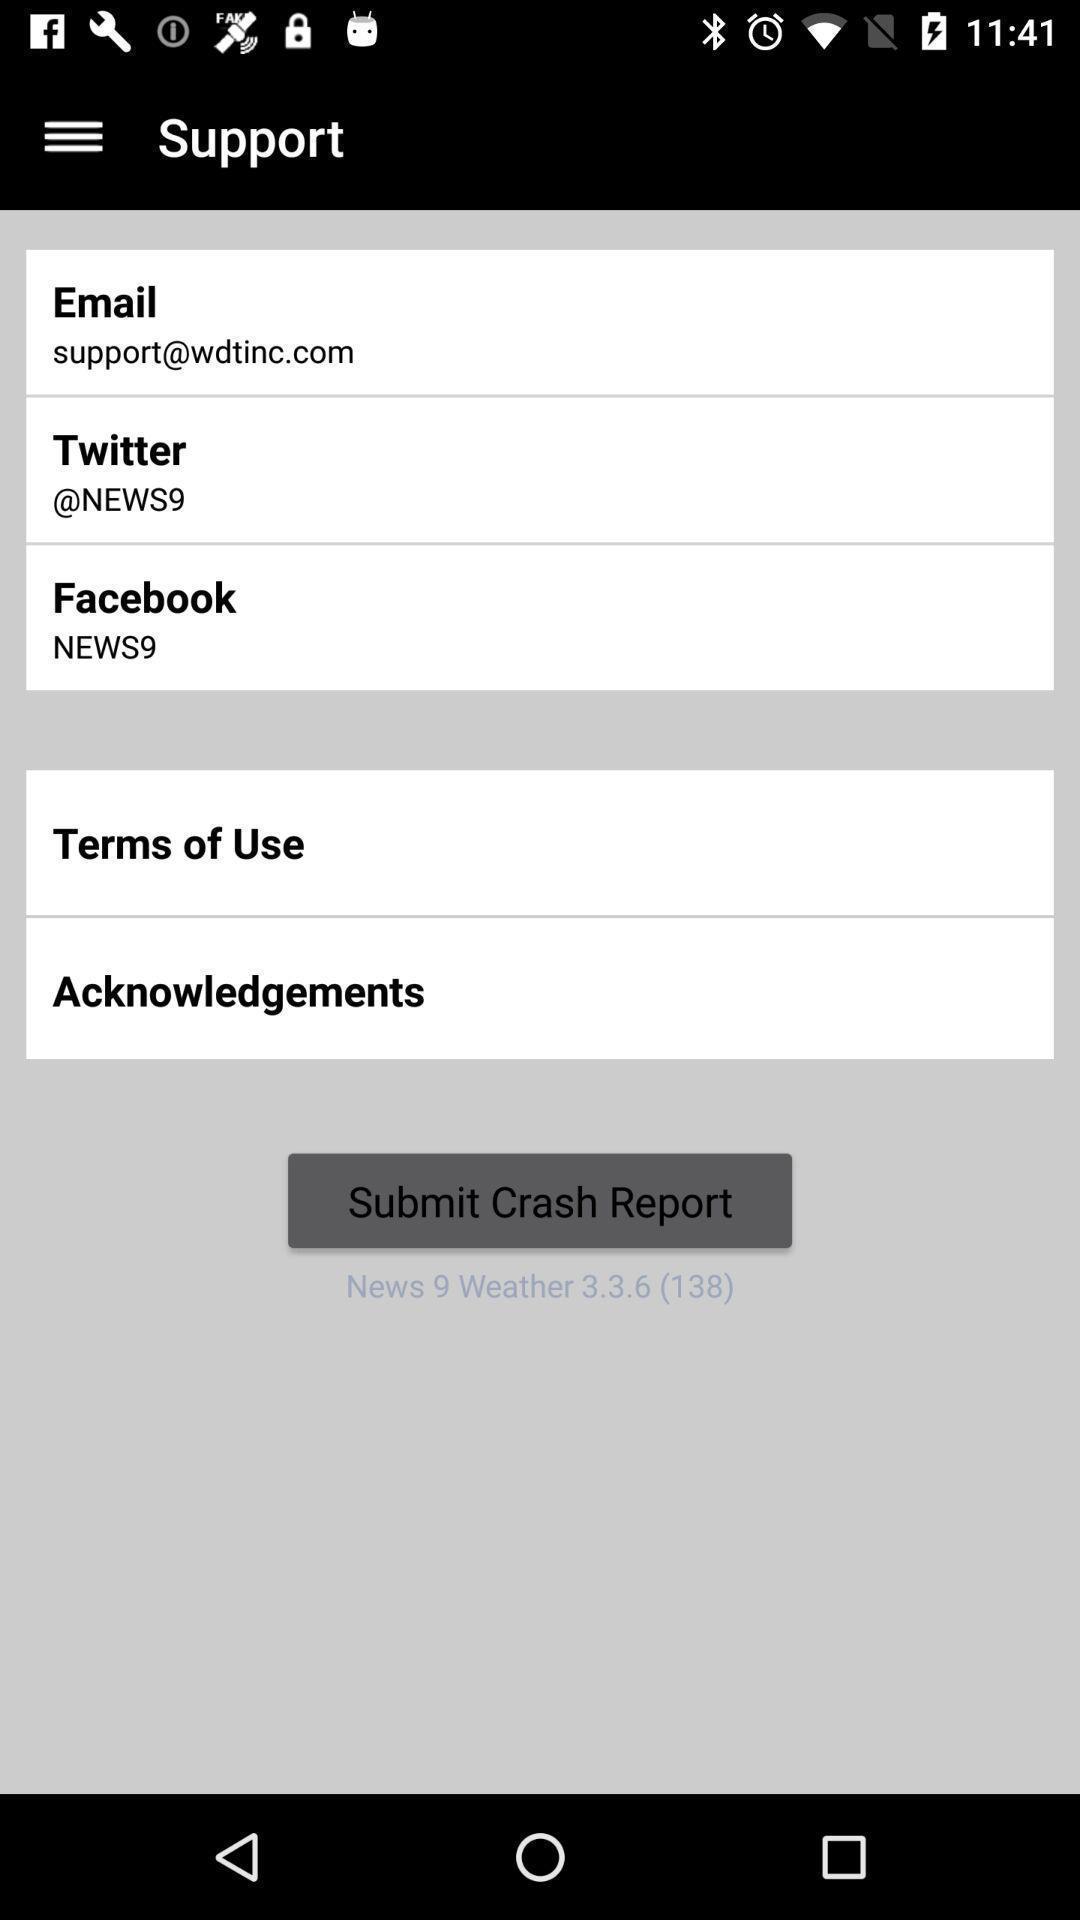Tell me what you see in this picture. Screen displaying a social id 's to submit report. 